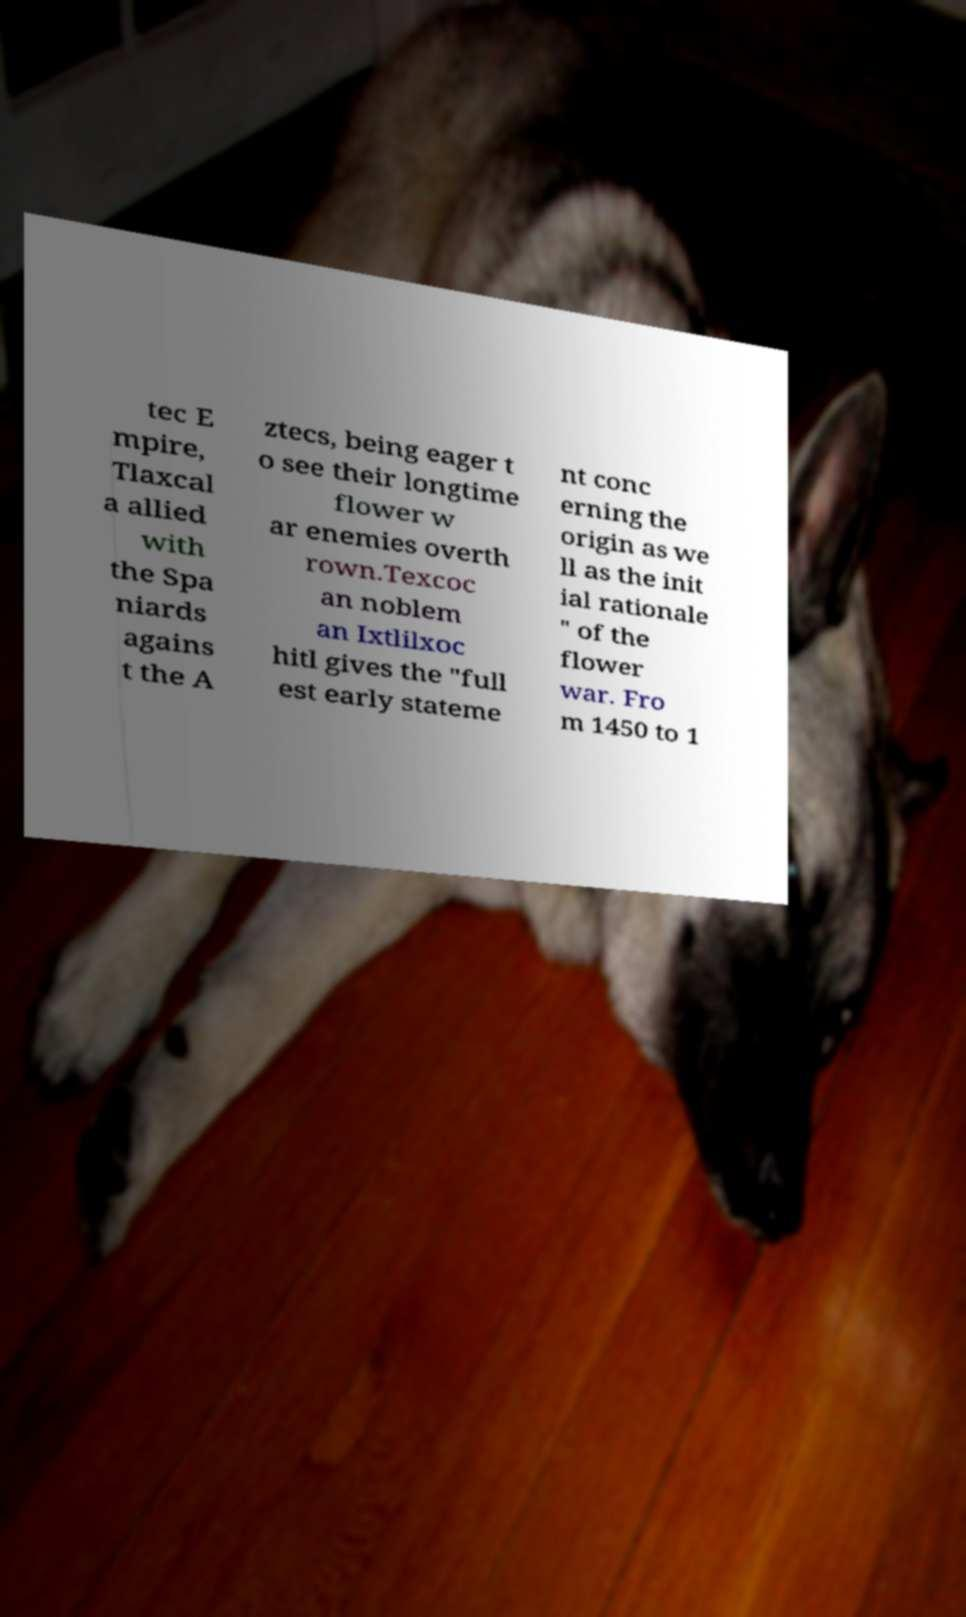What messages or text are displayed in this image? I need them in a readable, typed format. tec E mpire, Tlaxcal a allied with the Spa niards agains t the A ztecs, being eager t o see their longtime flower w ar enemies overth rown.Texcoc an noblem an Ixtlilxoc hitl gives the "full est early stateme nt conc erning the origin as we ll as the init ial rationale " of the flower war. Fro m 1450 to 1 